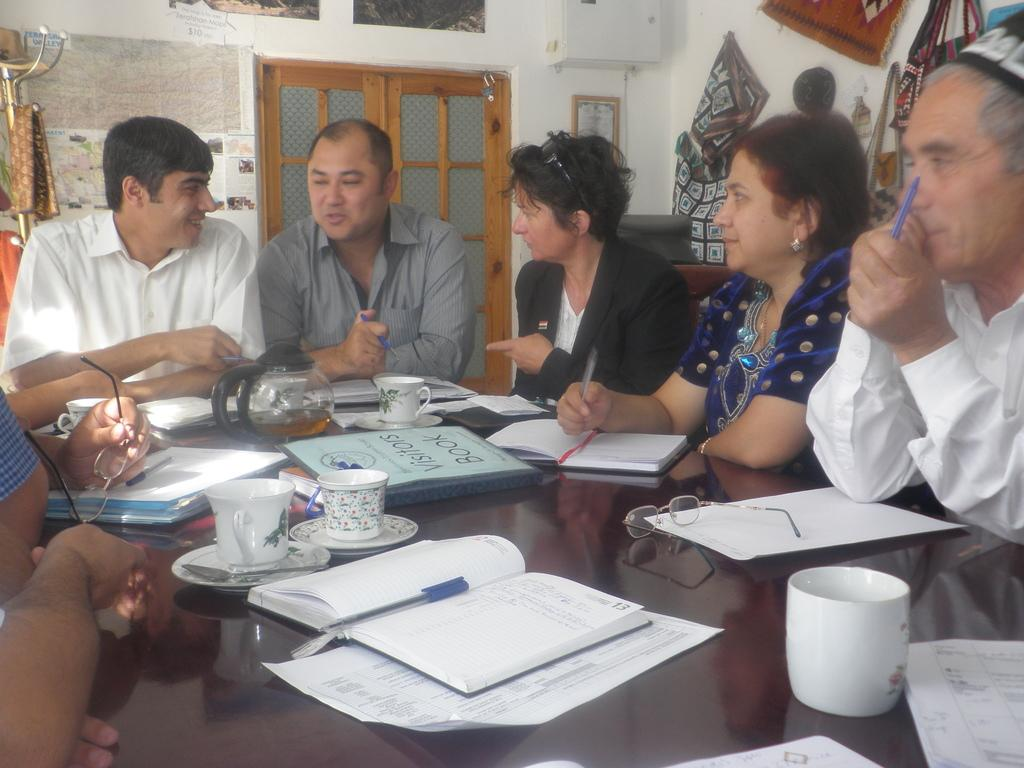What are the people in the image doing? The people in the image are sitting in chairs. What is in front of the people? There is a table in front of the people. What items can be seen on the table? There are books, papers, and cups on the table. Are there any other objects on the table? Yes, there are other objects on the table. Can you see a volcano erupting in the background of the image? There is no volcano present in the image. What note of disgust can be heard from the people in the image? There is no audio component to the image, and no indication of any emotion or reaction from the people. 